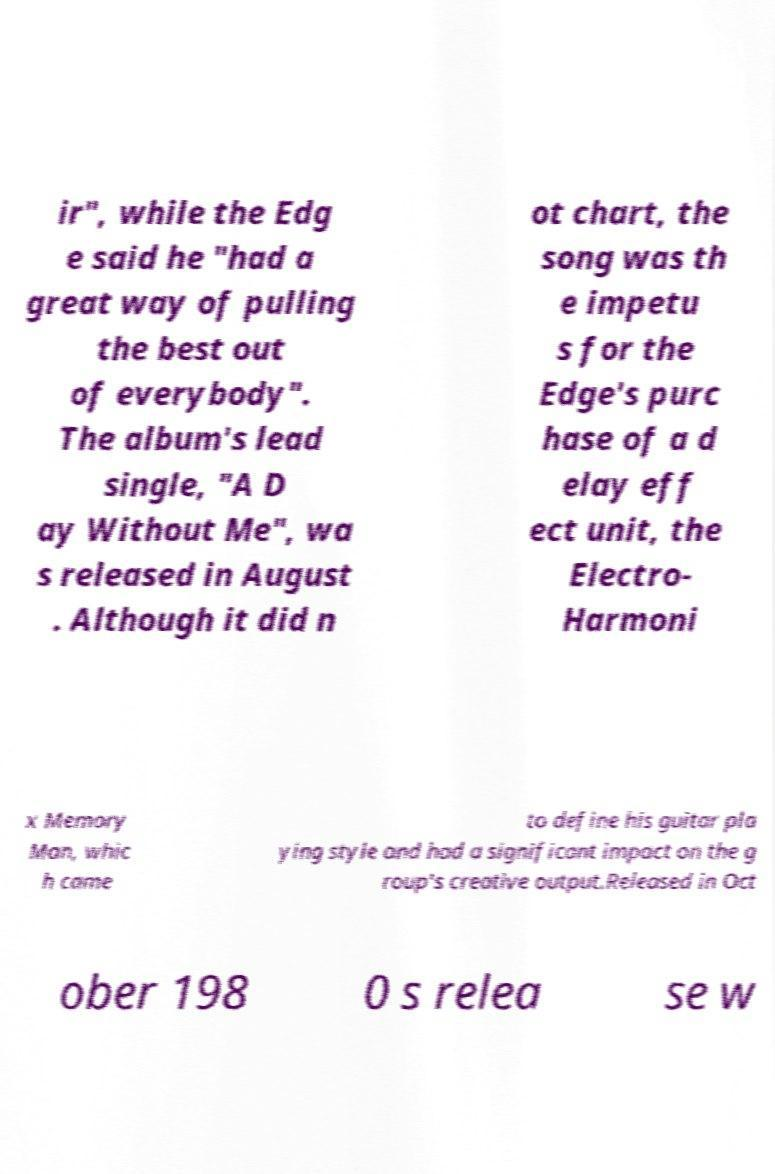There's text embedded in this image that I need extracted. Can you transcribe it verbatim? ir", while the Edg e said he "had a great way of pulling the best out of everybody". The album's lead single, "A D ay Without Me", wa s released in August . Although it did n ot chart, the song was th e impetu s for the Edge's purc hase of a d elay eff ect unit, the Electro- Harmoni x Memory Man, whic h came to define his guitar pla ying style and had a significant impact on the g roup's creative output.Released in Oct ober 198 0 s relea se w 